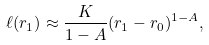<formula> <loc_0><loc_0><loc_500><loc_500>\ell ( r _ { 1 } ) \approx \frac { K } { 1 - A } ( r _ { 1 } - r _ { 0 } ) ^ { 1 - A } ,</formula> 